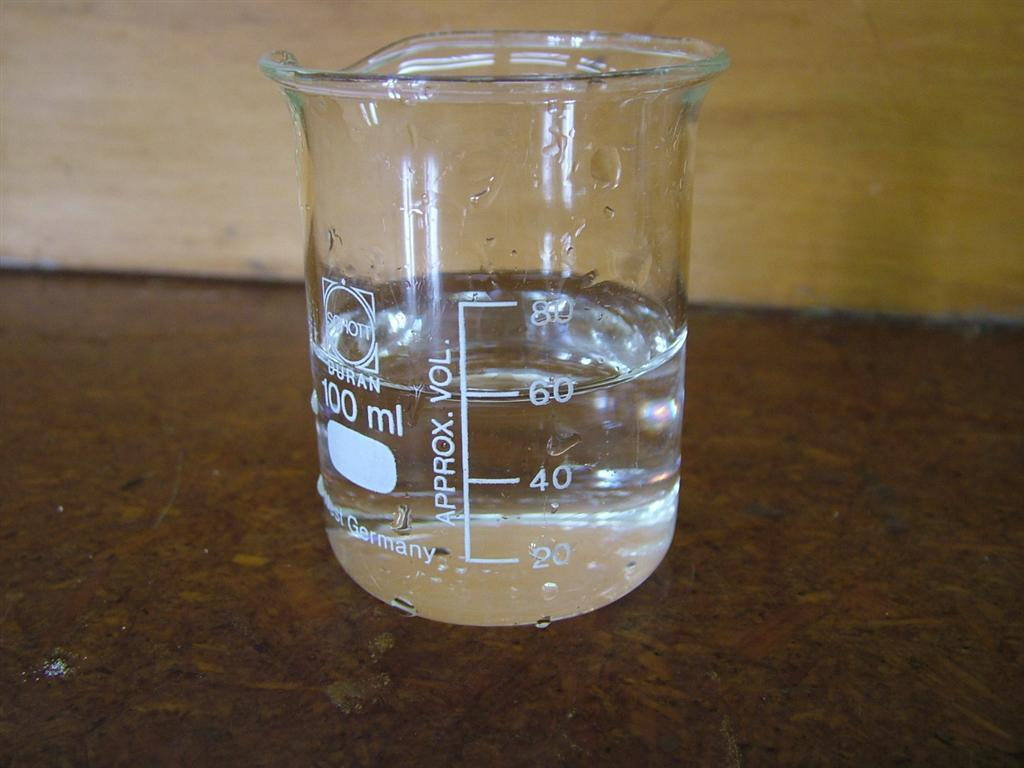<image>
Create a compact narrative representing the image presented. a cup with the letter 60 that is on it 